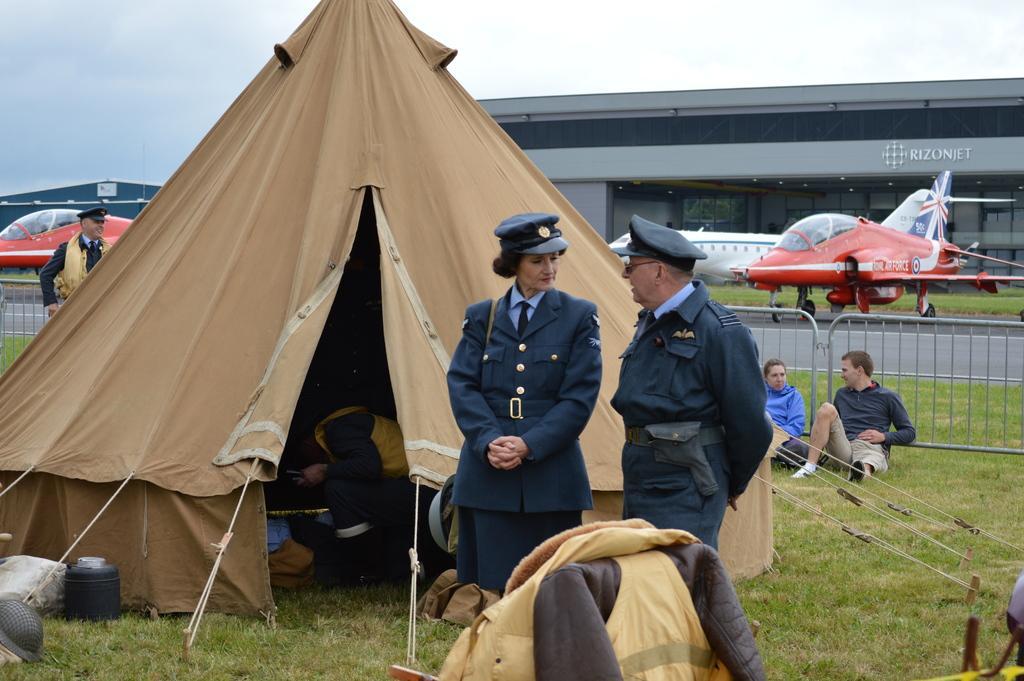How would you summarize this image in a sentence or two? In this image I can see the tent. There is a person inside the tent. To the side of the tent I can see few people. In the background I can see the railing, many aircraft and the building. I can also see the sky in the back. 